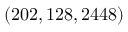<formula> <loc_0><loc_0><loc_500><loc_500>( 2 0 2 , 1 2 8 , 2 4 4 8 )</formula> 